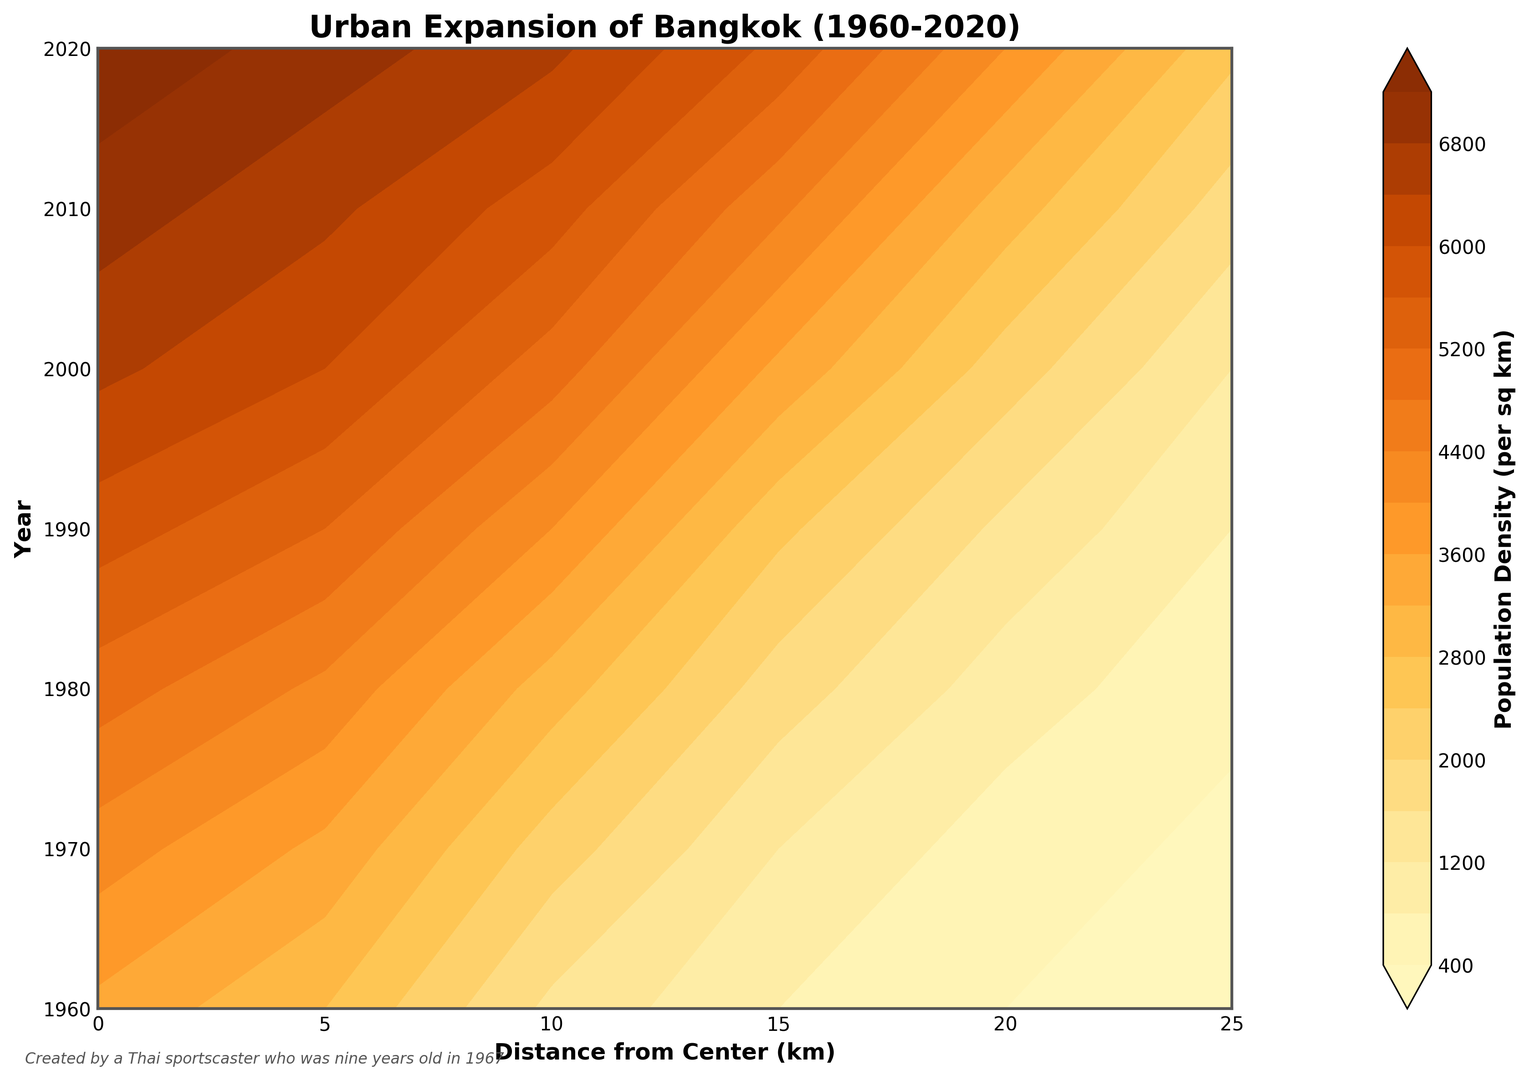What is the general trend of population density for the area within 5 km from the center from 1960 to 2020? Observing the contour gradient and colors, the population density increases from around 3500 people per sq km in 1960 to about 7000 people per sq km in 2020, indicating a steady increase over the years.
Answer: Steady increase Which year saw the highest population density at a distance of 10 km from the city center? Comparing the population density values along the 10 km distance, the deepest color (indicating the highest density) appears in 2020, with a density of 6500 people per sq km.
Answer: 2020 How does the population density at 15 km from the city center in 1980 compare to 2000? At 15 km, the contour color indicates a density of around 1800 per sq km in 1980 and 3500 per sq km in 2000, showing a notable increase.
Answer: Higher in 2000 What is the difference in population density at 20 km from the center between 1970 and 2020? In 1970, the density is 600 people per sq km and in 2020, it escalates to 4000 people per sq km. The difference is 4000 - 600 = 3400 people per sq km.
Answer: 3400 people per sq km What's the average population density for Bangkok at a 25 km radius for years 1960, 1970, and 1980 combined? The densities for these years are 200, 300, and 500 people per sq km respectively. The average is (200 + 300 + 500) / 3 = 333.33 people per sq km.
Answer: 333.33 people per sq km Which decade showed the largest increase in population density at a distance of 5 km from the center? By observing the change in density values at a 5 km distance, the increase from 4200 (1970) to 5000 (1980) is 800, from 5000 (1980) to 5800 (1990) is also 800, and from 5800 (1990) to 6500 (2000) is 700. The largest increase is actually from 6500 (2000) to 7000 (2010) which is 500. Hence, 1970 to 1980 shows the largest increase of 800.
Answer: 1970 to 1980 Can you identify the overall change in population density at the city center (0 km) from 1960 to 2020? In 1960, the density is 3500 people per sq km and in 2020, it's 7500 people per sq km. The change is 7500 - 3500 = 4000 people per sq km.
Answer: 4000 people per sq km What is the median population density at 10 km from the city center, taking all years into consideration? The population densities at 10 km are 1500 (1960), 2200 (1970), 3000 (1980), 4000 (1990), 5000 (2000), 5800 (2010), and 6500 (2020). Ordering these values gives: 1500, 2200, 3000, 4000, 5000, 5800, 6500, with the median being the fourth value, 4000.
Answer: 4000 people per sq km At what distance from the city center does the population density appear to stabilize by 2020? Observing the contour plot for 2020 from the center moving outward, the density increases significantly up to 15 km and stabilizes from 20 km onward, indicated by a lighter color gradient.
Answer: 20 km How does the color gradient in the plot help interpret the changes in population density over the years? The contour plot uses a color gradient from light to dark shades to depict the increasing population density, where lighter shades represent lower density and darker shades represent higher density, making it visually straightforward to identify growth trends and density changes.
Answer: Depicts density changes through shades 